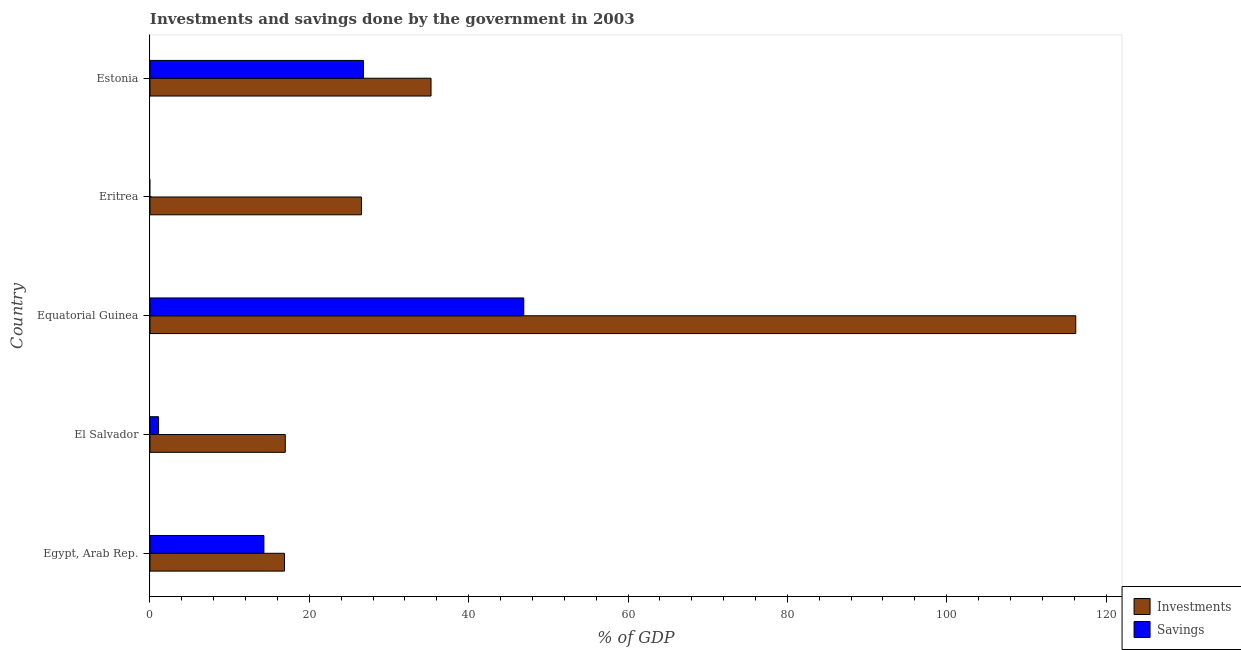How many different coloured bars are there?
Offer a terse response. 2. Are the number of bars per tick equal to the number of legend labels?
Give a very brief answer. No. Are the number of bars on each tick of the Y-axis equal?
Provide a short and direct response. No. How many bars are there on the 2nd tick from the top?
Give a very brief answer. 1. How many bars are there on the 4th tick from the bottom?
Keep it short and to the point. 1. What is the label of the 3rd group of bars from the top?
Ensure brevity in your answer.  Equatorial Guinea. In how many cases, is the number of bars for a given country not equal to the number of legend labels?
Provide a short and direct response. 1. What is the investments of government in Estonia?
Provide a short and direct response. 35.28. Across all countries, what is the maximum investments of government?
Make the answer very short. 116.2. In which country was the investments of government maximum?
Give a very brief answer. Equatorial Guinea. What is the total investments of government in the graph?
Keep it short and to the point. 211.89. What is the difference between the investments of government in Egypt, Arab Rep. and that in Estonia?
Give a very brief answer. -18.39. What is the difference between the investments of government in Eritrea and the savings of government in El Salvador?
Your answer should be compact. 25.47. What is the average savings of government per country?
Keep it short and to the point. 17.82. What is the difference between the savings of government and investments of government in El Salvador?
Your response must be concise. -15.91. Is the difference between the investments of government in Egypt, Arab Rep. and El Salvador greater than the difference between the savings of government in Egypt, Arab Rep. and El Salvador?
Your response must be concise. No. What is the difference between the highest and the second highest savings of government?
Offer a very short reply. 20.13. What is the difference between the highest and the lowest savings of government?
Offer a terse response. 46.92. How many bars are there?
Offer a terse response. 9. Are all the bars in the graph horizontal?
Give a very brief answer. Yes. How many countries are there in the graph?
Make the answer very short. 5. Are the values on the major ticks of X-axis written in scientific E-notation?
Offer a very short reply. No. Does the graph contain any zero values?
Make the answer very short. Yes. Where does the legend appear in the graph?
Provide a succinct answer. Bottom right. How many legend labels are there?
Make the answer very short. 2. What is the title of the graph?
Provide a short and direct response. Investments and savings done by the government in 2003. Does "Secondary education" appear as one of the legend labels in the graph?
Ensure brevity in your answer.  No. What is the label or title of the X-axis?
Offer a terse response. % of GDP. What is the label or title of the Y-axis?
Keep it short and to the point. Country. What is the % of GDP of Investments in Egypt, Arab Rep.?
Offer a very short reply. 16.89. What is the % of GDP in Savings in Egypt, Arab Rep.?
Your answer should be very brief. 14.3. What is the % of GDP of Investments in El Salvador?
Provide a short and direct response. 16.98. What is the % of GDP of Savings in El Salvador?
Provide a short and direct response. 1.07. What is the % of GDP of Investments in Equatorial Guinea?
Make the answer very short. 116.2. What is the % of GDP in Savings in Equatorial Guinea?
Provide a succinct answer. 46.92. What is the % of GDP of Investments in Eritrea?
Offer a very short reply. 26.54. What is the % of GDP in Investments in Estonia?
Keep it short and to the point. 35.28. What is the % of GDP of Savings in Estonia?
Offer a very short reply. 26.79. Across all countries, what is the maximum % of GDP in Investments?
Your response must be concise. 116.2. Across all countries, what is the maximum % of GDP in Savings?
Your response must be concise. 46.92. Across all countries, what is the minimum % of GDP in Investments?
Offer a terse response. 16.89. Across all countries, what is the minimum % of GDP in Savings?
Make the answer very short. 0. What is the total % of GDP in Investments in the graph?
Ensure brevity in your answer.  211.89. What is the total % of GDP of Savings in the graph?
Ensure brevity in your answer.  89.08. What is the difference between the % of GDP in Investments in Egypt, Arab Rep. and that in El Salvador?
Offer a terse response. -0.09. What is the difference between the % of GDP in Savings in Egypt, Arab Rep. and that in El Salvador?
Provide a short and direct response. 13.22. What is the difference between the % of GDP in Investments in Egypt, Arab Rep. and that in Equatorial Guinea?
Your answer should be compact. -99.32. What is the difference between the % of GDP of Savings in Egypt, Arab Rep. and that in Equatorial Guinea?
Offer a very short reply. -32.62. What is the difference between the % of GDP in Investments in Egypt, Arab Rep. and that in Eritrea?
Provide a succinct answer. -9.66. What is the difference between the % of GDP of Investments in Egypt, Arab Rep. and that in Estonia?
Keep it short and to the point. -18.39. What is the difference between the % of GDP of Savings in Egypt, Arab Rep. and that in Estonia?
Your answer should be compact. -12.49. What is the difference between the % of GDP in Investments in El Salvador and that in Equatorial Guinea?
Ensure brevity in your answer.  -99.22. What is the difference between the % of GDP of Savings in El Salvador and that in Equatorial Guinea?
Make the answer very short. -45.84. What is the difference between the % of GDP of Investments in El Salvador and that in Eritrea?
Provide a short and direct response. -9.56. What is the difference between the % of GDP in Investments in El Salvador and that in Estonia?
Your answer should be compact. -18.3. What is the difference between the % of GDP of Savings in El Salvador and that in Estonia?
Provide a succinct answer. -25.72. What is the difference between the % of GDP of Investments in Equatorial Guinea and that in Eritrea?
Your response must be concise. 89.66. What is the difference between the % of GDP in Investments in Equatorial Guinea and that in Estonia?
Provide a short and direct response. 80.93. What is the difference between the % of GDP of Savings in Equatorial Guinea and that in Estonia?
Give a very brief answer. 20.13. What is the difference between the % of GDP in Investments in Eritrea and that in Estonia?
Your answer should be compact. -8.73. What is the difference between the % of GDP in Investments in Egypt, Arab Rep. and the % of GDP in Savings in El Salvador?
Your answer should be very brief. 15.81. What is the difference between the % of GDP in Investments in Egypt, Arab Rep. and the % of GDP in Savings in Equatorial Guinea?
Your answer should be very brief. -30.03. What is the difference between the % of GDP of Investments in Egypt, Arab Rep. and the % of GDP of Savings in Estonia?
Provide a succinct answer. -9.9. What is the difference between the % of GDP in Investments in El Salvador and the % of GDP in Savings in Equatorial Guinea?
Your response must be concise. -29.94. What is the difference between the % of GDP in Investments in El Salvador and the % of GDP in Savings in Estonia?
Provide a succinct answer. -9.81. What is the difference between the % of GDP in Investments in Equatorial Guinea and the % of GDP in Savings in Estonia?
Your answer should be compact. 89.41. What is the difference between the % of GDP of Investments in Eritrea and the % of GDP of Savings in Estonia?
Ensure brevity in your answer.  -0.25. What is the average % of GDP of Investments per country?
Keep it short and to the point. 42.38. What is the average % of GDP in Savings per country?
Keep it short and to the point. 17.82. What is the difference between the % of GDP in Investments and % of GDP in Savings in Egypt, Arab Rep.?
Provide a short and direct response. 2.59. What is the difference between the % of GDP in Investments and % of GDP in Savings in El Salvador?
Offer a terse response. 15.91. What is the difference between the % of GDP of Investments and % of GDP of Savings in Equatorial Guinea?
Provide a short and direct response. 69.29. What is the difference between the % of GDP of Investments and % of GDP of Savings in Estonia?
Provide a short and direct response. 8.49. What is the ratio of the % of GDP in Investments in Egypt, Arab Rep. to that in El Salvador?
Keep it short and to the point. 0.99. What is the ratio of the % of GDP in Savings in Egypt, Arab Rep. to that in El Salvador?
Offer a terse response. 13.31. What is the ratio of the % of GDP of Investments in Egypt, Arab Rep. to that in Equatorial Guinea?
Make the answer very short. 0.15. What is the ratio of the % of GDP of Savings in Egypt, Arab Rep. to that in Equatorial Guinea?
Ensure brevity in your answer.  0.3. What is the ratio of the % of GDP of Investments in Egypt, Arab Rep. to that in Eritrea?
Give a very brief answer. 0.64. What is the ratio of the % of GDP in Investments in Egypt, Arab Rep. to that in Estonia?
Ensure brevity in your answer.  0.48. What is the ratio of the % of GDP of Savings in Egypt, Arab Rep. to that in Estonia?
Your answer should be very brief. 0.53. What is the ratio of the % of GDP of Investments in El Salvador to that in Equatorial Guinea?
Keep it short and to the point. 0.15. What is the ratio of the % of GDP of Savings in El Salvador to that in Equatorial Guinea?
Your answer should be very brief. 0.02. What is the ratio of the % of GDP of Investments in El Salvador to that in Eritrea?
Make the answer very short. 0.64. What is the ratio of the % of GDP of Investments in El Salvador to that in Estonia?
Your answer should be very brief. 0.48. What is the ratio of the % of GDP of Savings in El Salvador to that in Estonia?
Offer a very short reply. 0.04. What is the ratio of the % of GDP in Investments in Equatorial Guinea to that in Eritrea?
Give a very brief answer. 4.38. What is the ratio of the % of GDP of Investments in Equatorial Guinea to that in Estonia?
Give a very brief answer. 3.29. What is the ratio of the % of GDP in Savings in Equatorial Guinea to that in Estonia?
Provide a succinct answer. 1.75. What is the ratio of the % of GDP in Investments in Eritrea to that in Estonia?
Make the answer very short. 0.75. What is the difference between the highest and the second highest % of GDP in Investments?
Your answer should be compact. 80.93. What is the difference between the highest and the second highest % of GDP in Savings?
Your answer should be very brief. 20.13. What is the difference between the highest and the lowest % of GDP of Investments?
Provide a short and direct response. 99.32. What is the difference between the highest and the lowest % of GDP in Savings?
Provide a succinct answer. 46.92. 